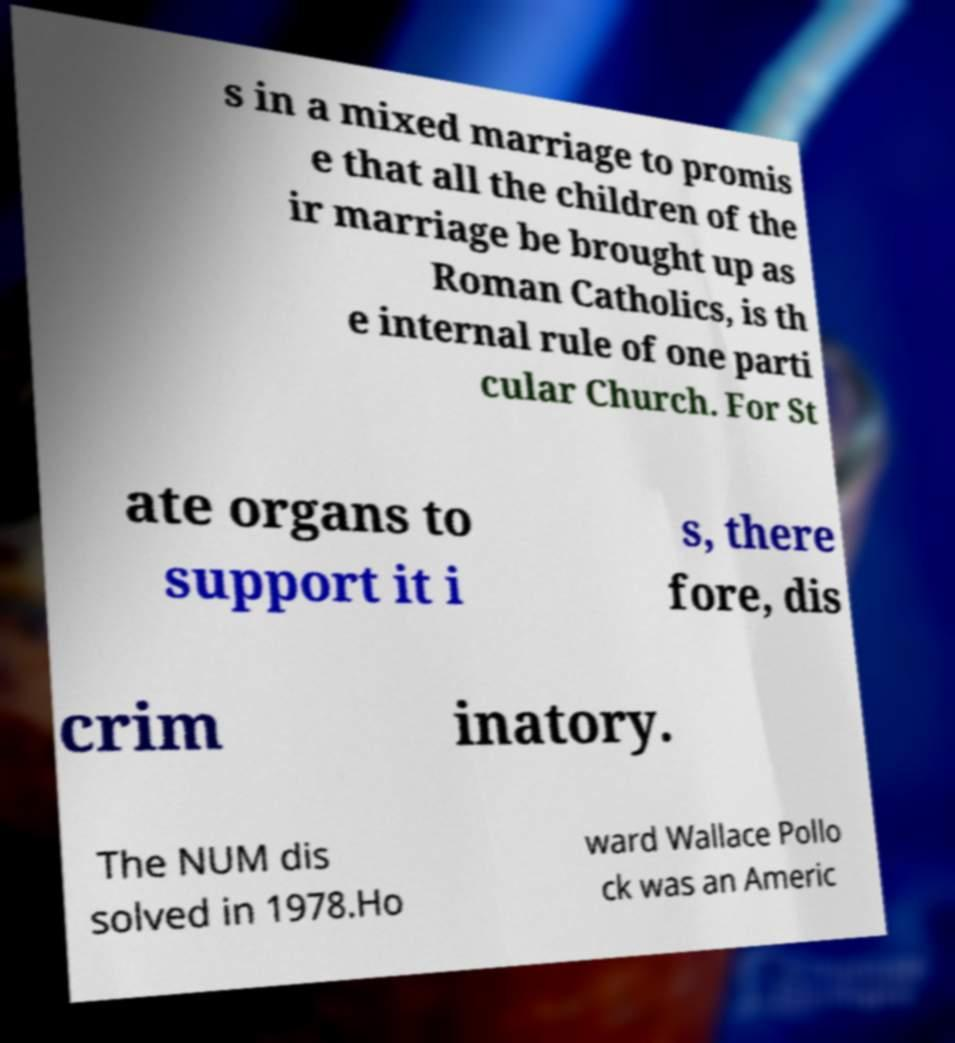Could you assist in decoding the text presented in this image and type it out clearly? s in a mixed marriage to promis e that all the children of the ir marriage be brought up as Roman Catholics, is th e internal rule of one parti cular Church. For St ate organs to support it i s, there fore, dis crim inatory. The NUM dis solved in 1978.Ho ward Wallace Pollo ck was an Americ 